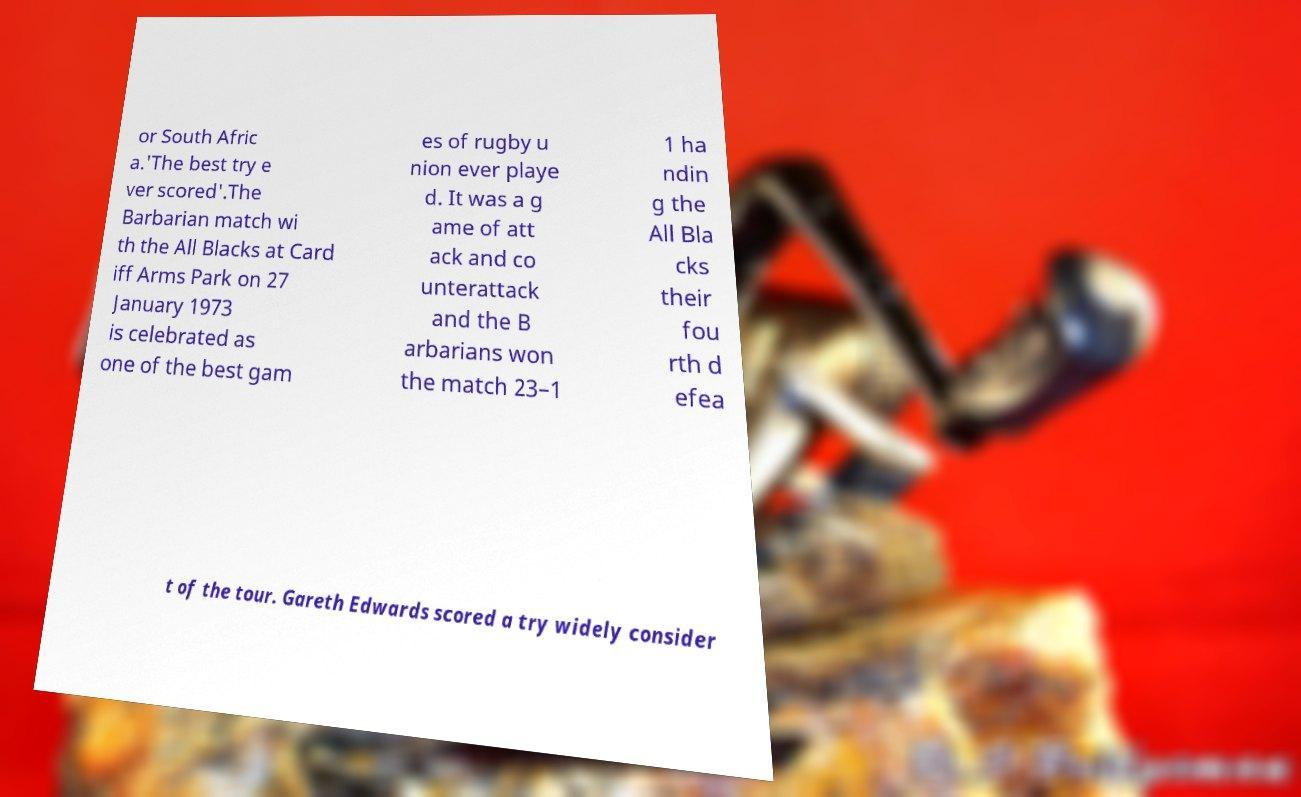There's text embedded in this image that I need extracted. Can you transcribe it verbatim? or South Afric a.'The best try e ver scored'.The Barbarian match wi th the All Blacks at Card iff Arms Park on 27 January 1973 is celebrated as one of the best gam es of rugby u nion ever playe d. It was a g ame of att ack and co unterattack and the B arbarians won the match 23–1 1 ha ndin g the All Bla cks their fou rth d efea t of the tour. Gareth Edwards scored a try widely consider 